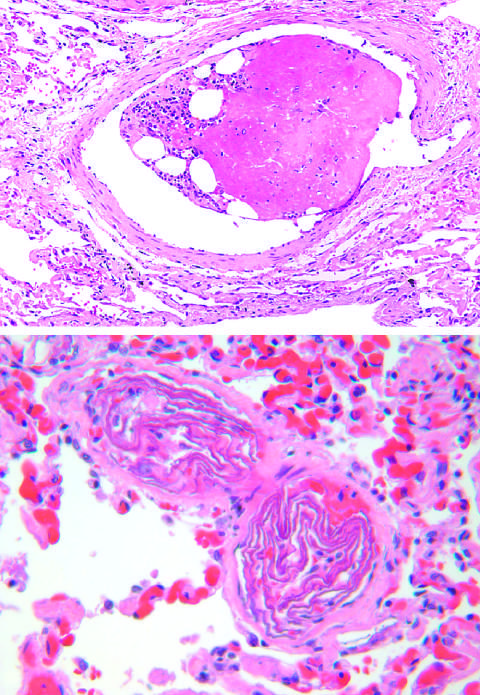s numerous friable mural thrombi edematous and congested?
Answer the question using a single word or phrase. No 